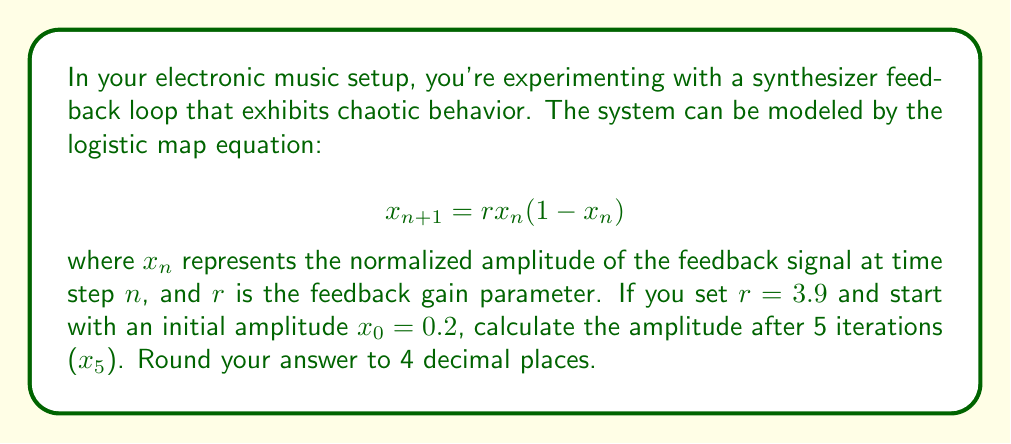Give your solution to this math problem. Let's iterate through the logistic map equation step by step:

1) For $n = 0$:
   $x_1 = 3.9 \cdot 0.2 \cdot (1-0.2) = 3.9 \cdot 0.2 \cdot 0.8 = 0.624$

2) For $n = 1$:
   $x_2 = 3.9 \cdot 0.624 \cdot (1-0.624) = 3.9 \cdot 0.624 \cdot 0.376 = 0.9165984$

3) For $n = 2$:
   $x_3 = 3.9 \cdot 0.9165984 \cdot (1-0.9165984) = 3.9 \cdot 0.9165984 \cdot 0.0834016 = 0.2976534$

4) For $n = 3$:
   $x_4 = 3.9 \cdot 0.2976534 \cdot (1-0.2976534) = 3.9 \cdot 0.2976534 \cdot 0.7023466 = 0.8159633$

5) For $n = 4$:
   $x_5 = 3.9 \cdot 0.8159633 \cdot (1-0.8159633) = 3.9 \cdot 0.8159633 \cdot 0.1840367 = 0.5850649$

Rounding to 4 decimal places: 0.5851
Answer: 0.5851 